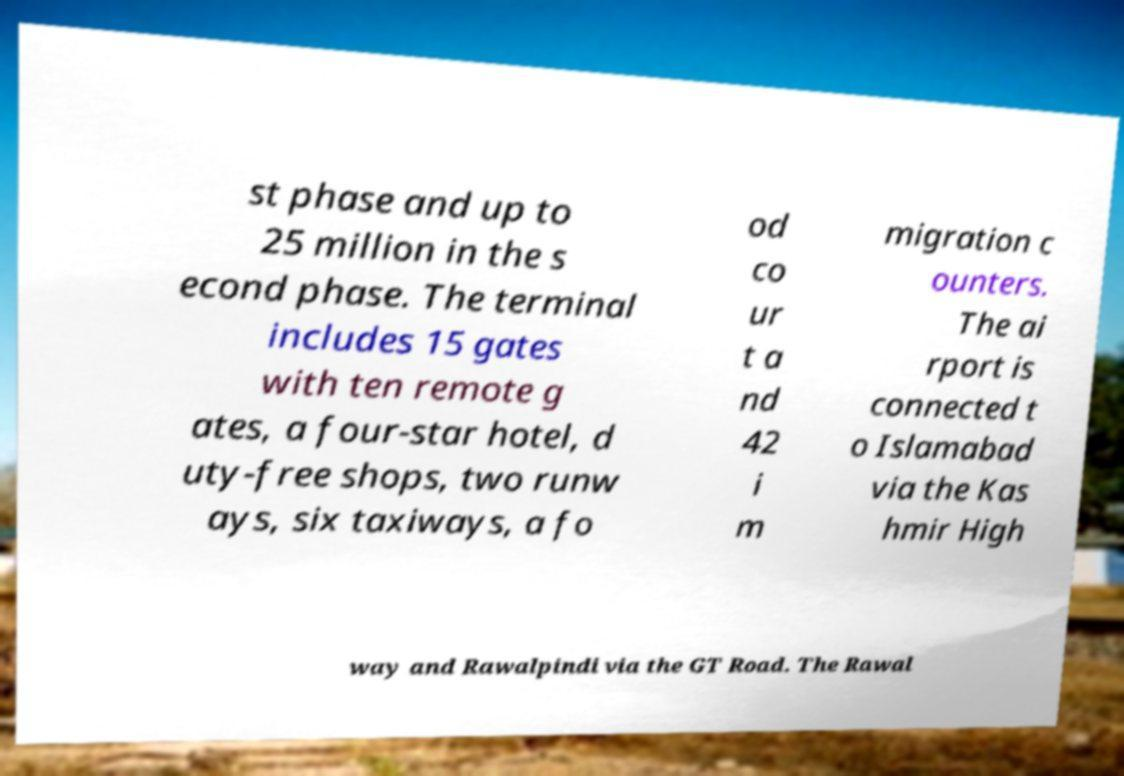Please read and relay the text visible in this image. What does it say? st phase and up to 25 million in the s econd phase. The terminal includes 15 gates with ten remote g ates, a four-star hotel, d uty-free shops, two runw ays, six taxiways, a fo od co ur t a nd 42 i m migration c ounters. The ai rport is connected t o Islamabad via the Kas hmir High way and Rawalpindi via the GT Road. The Rawal 